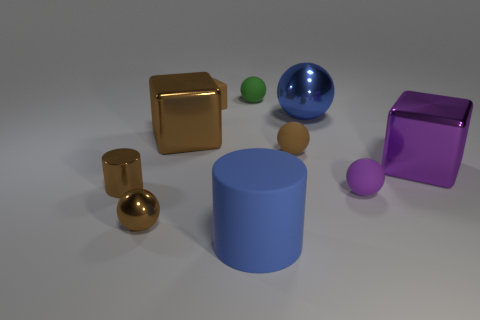Subtract all big metallic balls. How many balls are left? 4 Add 7 tiny rubber cubes. How many tiny rubber cubes are left? 8 Add 3 big purple shiny objects. How many big purple shiny objects exist? 4 Subtract all green balls. How many balls are left? 4 Subtract 0 red blocks. How many objects are left? 10 Subtract all cylinders. How many objects are left? 8 Subtract 2 cylinders. How many cylinders are left? 0 Subtract all red balls. Subtract all green cylinders. How many balls are left? 5 Subtract all cyan cylinders. How many purple spheres are left? 1 Subtract all rubber things. Subtract all large brown metal cylinders. How many objects are left? 5 